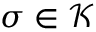Convert formula to latex. <formula><loc_0><loc_0><loc_500><loc_500>\sigma \in { \mathcal { K } }</formula> 